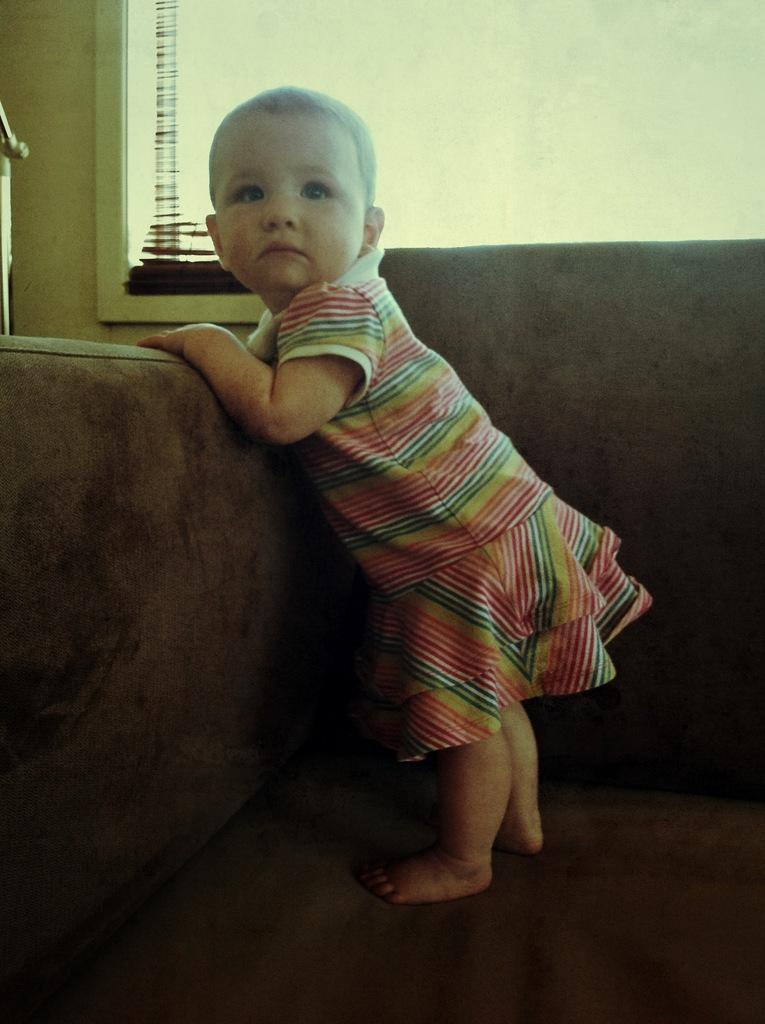What is the main subject of the picture? The main subject of the picture is a baby. What is the baby doing in the image? The baby is standing on a sofa. What can be seen in the background of the image? There appears to be a window in the background of the image. What is the aftermath of the baby's jump in the image? There is no jump depicted in the image; the baby is standing on the sofa. How many hands are visible in the image? The number of hands cannot be determined from the image, as it only shows the baby standing on a sofa and a window in the background. 